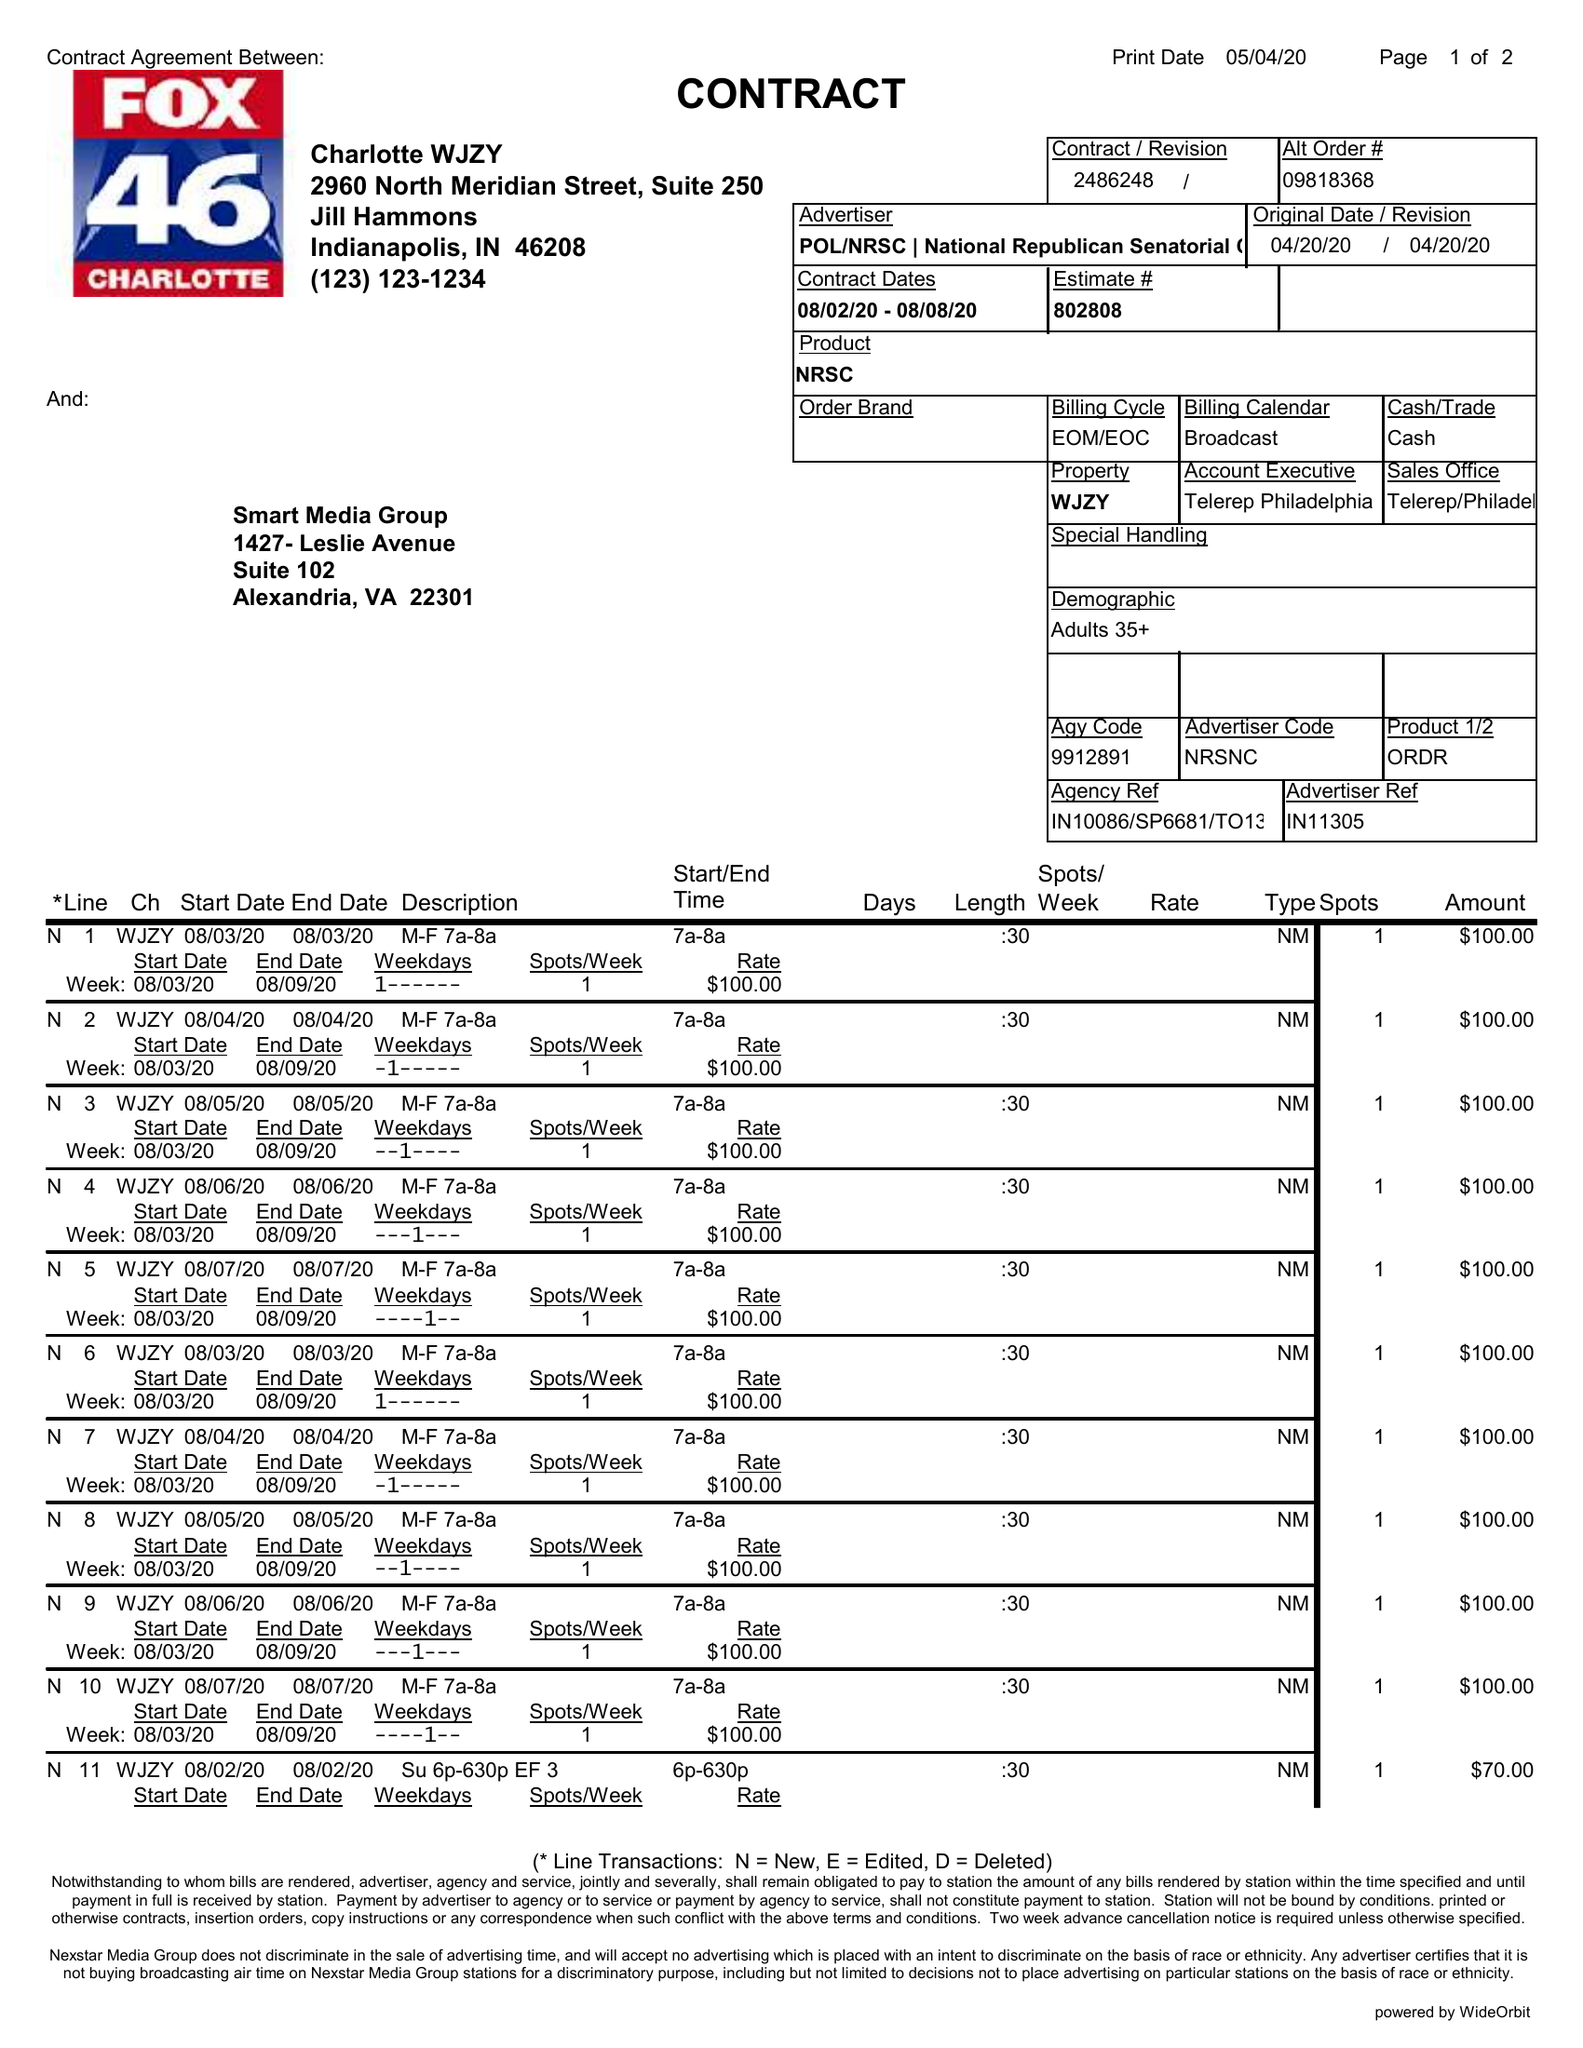What is the value for the flight_to?
Answer the question using a single word or phrase. 08/08/20 